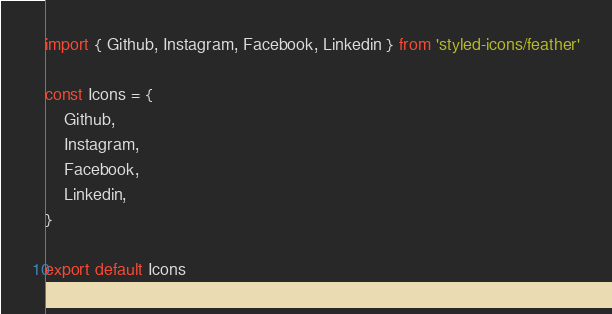Convert code to text. <code><loc_0><loc_0><loc_500><loc_500><_JavaScript_>import { Github, Instagram, Facebook, Linkedin } from 'styled-icons/feather'

const Icons = {
    Github,
    Instagram,
    Facebook,
    Linkedin,
}

export default Icons</code> 